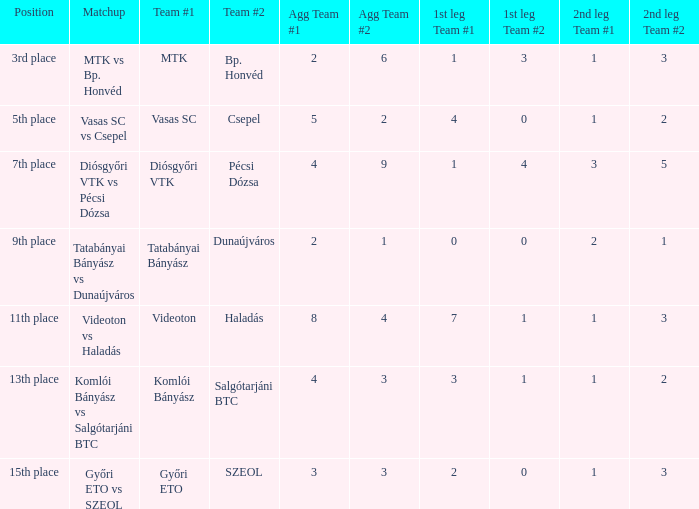What is the 1st leg of bp. honvéd team #2? 1-3. 